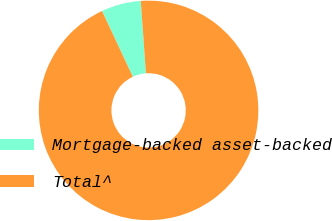Convert chart. <chart><loc_0><loc_0><loc_500><loc_500><pie_chart><fcel>Mortgage-backed asset-backed<fcel>Total^<nl><fcel>5.84%<fcel>94.16%<nl></chart> 